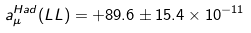Convert formula to latex. <formula><loc_0><loc_0><loc_500><loc_500>a _ { \mu } ^ { H a d } ( L L ) = + 8 9 . 6 \pm 1 5 . 4 \times 1 0 ^ { - 1 1 }</formula> 